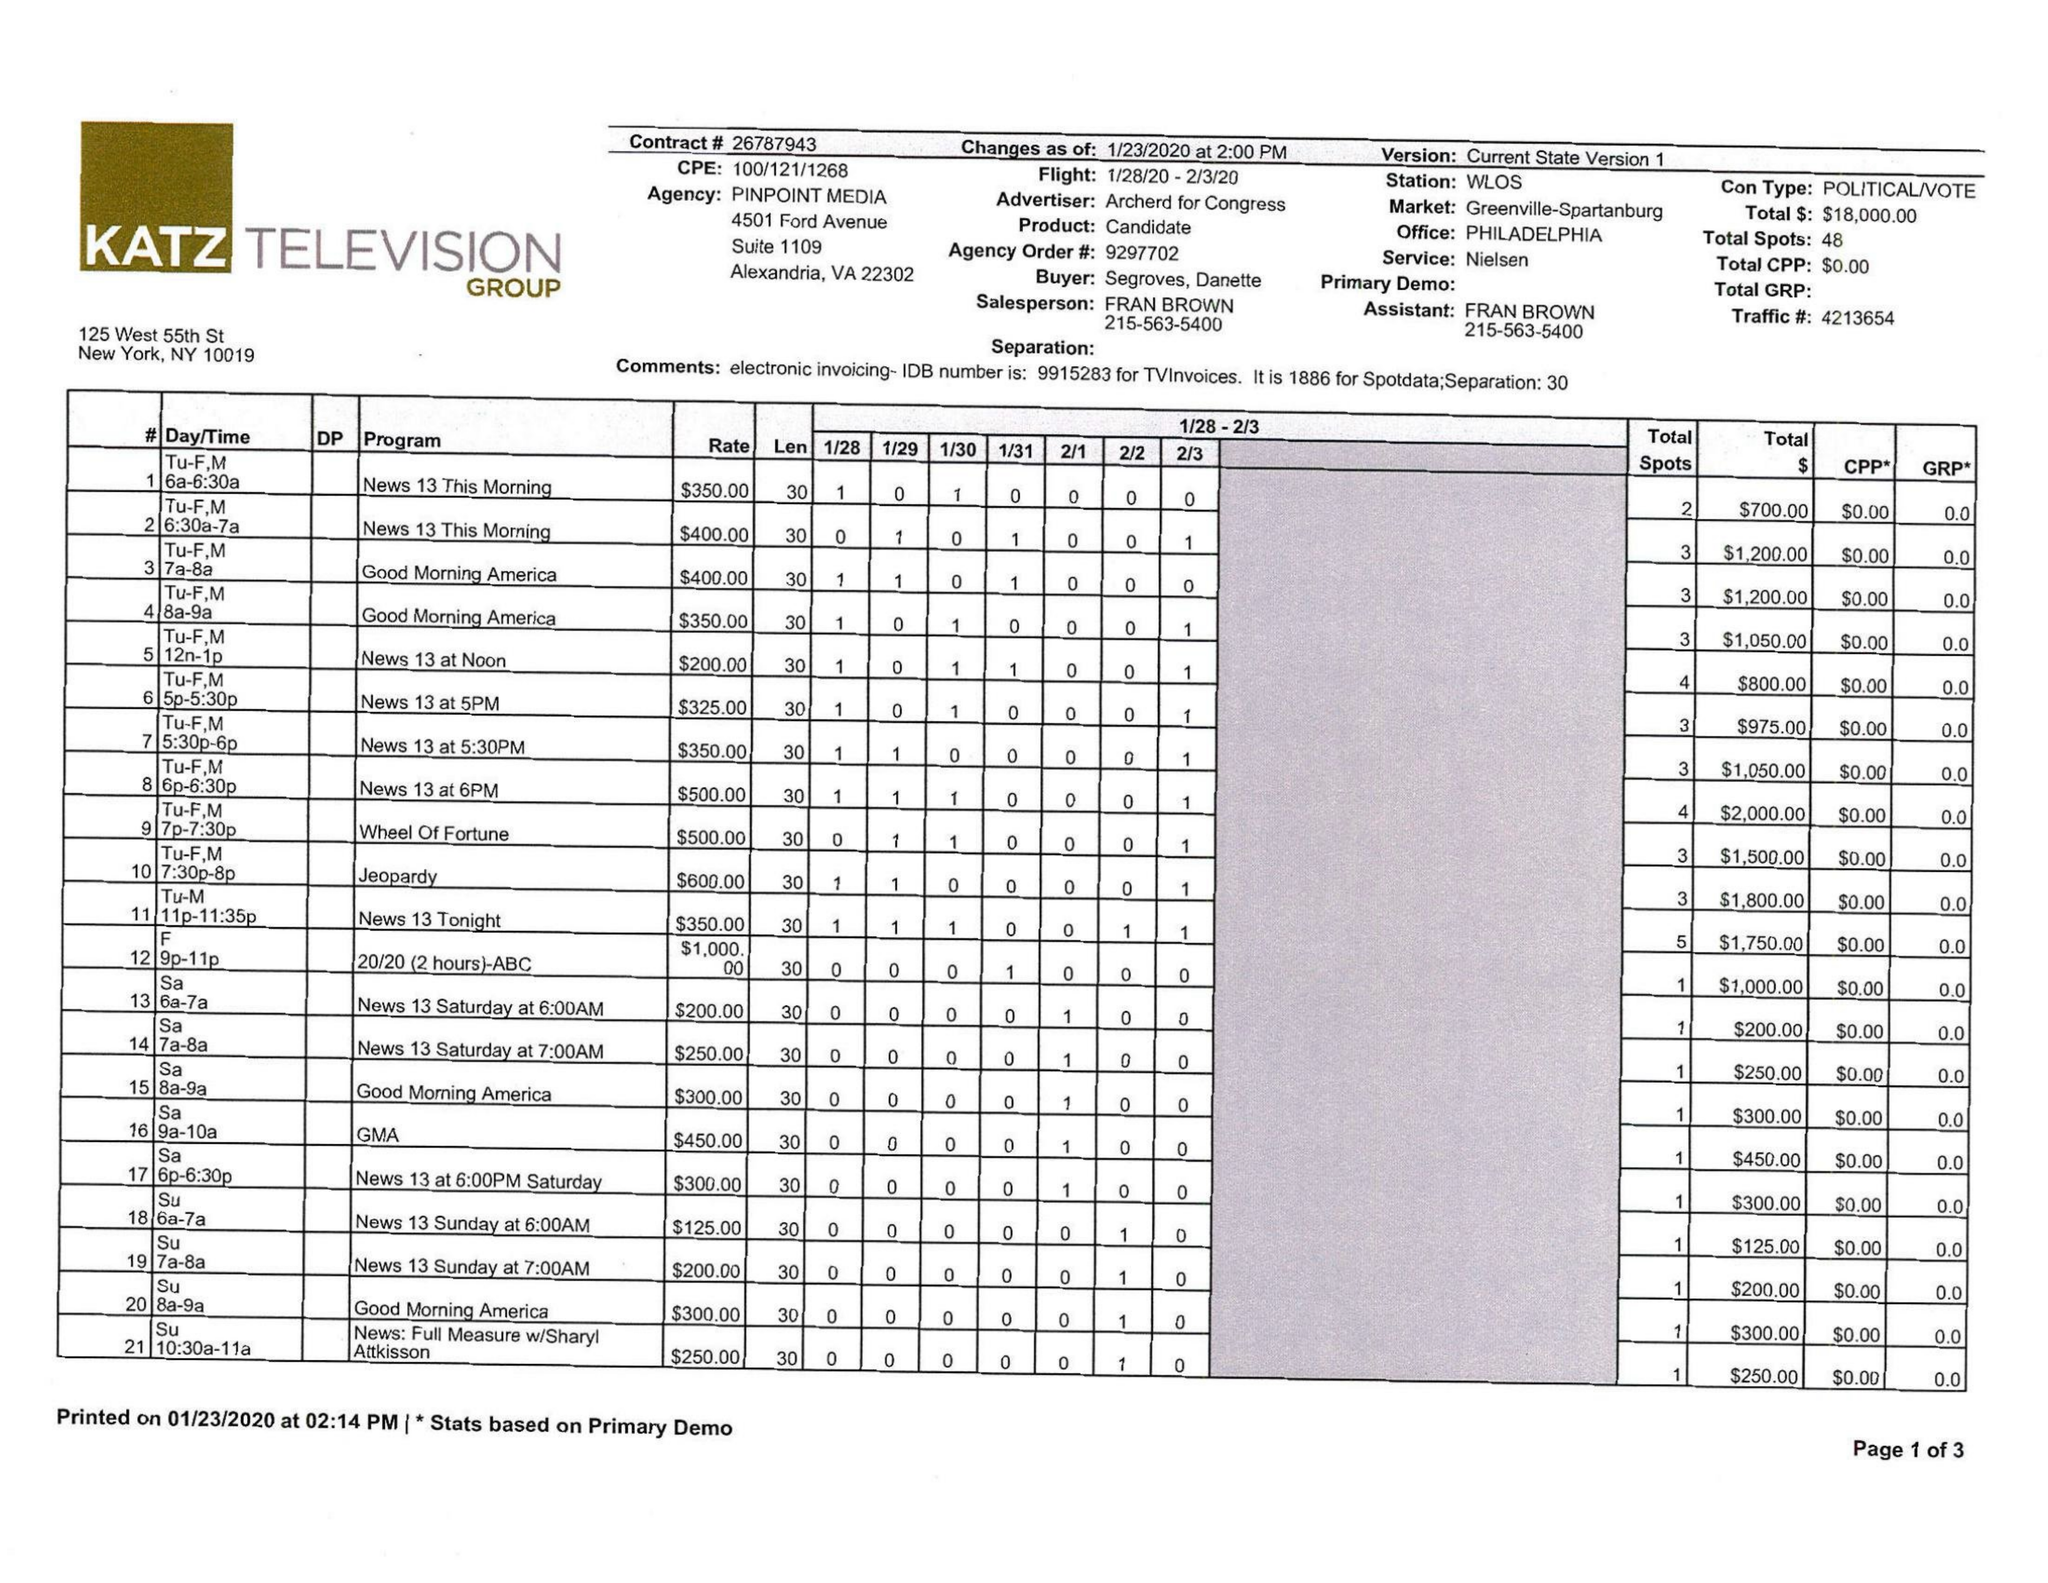What is the value for the flight_to?
Answer the question using a single word or phrase. 02/03/20 